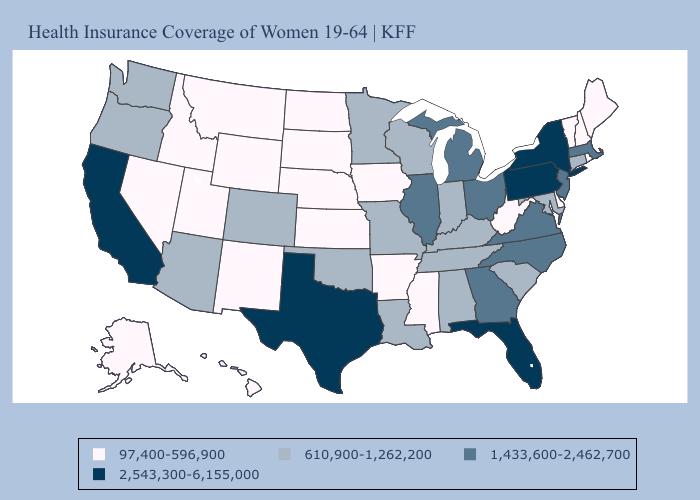What is the lowest value in the South?
Short answer required. 97,400-596,900. Does West Virginia have a higher value than Minnesota?
Be succinct. No. Name the states that have a value in the range 1,433,600-2,462,700?
Keep it brief. Georgia, Illinois, Massachusetts, Michigan, New Jersey, North Carolina, Ohio, Virginia. Does Wisconsin have the same value as South Dakota?
Answer briefly. No. What is the lowest value in states that border South Dakota?
Concise answer only. 97,400-596,900. How many symbols are there in the legend?
Be succinct. 4. Does Texas have the highest value in the USA?
Give a very brief answer. Yes. What is the value of Colorado?
Answer briefly. 610,900-1,262,200. Does Arizona have a higher value than Minnesota?
Answer briefly. No. How many symbols are there in the legend?
Answer briefly. 4. Name the states that have a value in the range 610,900-1,262,200?
Answer briefly. Alabama, Arizona, Colorado, Connecticut, Indiana, Kentucky, Louisiana, Maryland, Minnesota, Missouri, Oklahoma, Oregon, South Carolina, Tennessee, Washington, Wisconsin. Name the states that have a value in the range 2,543,300-6,155,000?
Quick response, please. California, Florida, New York, Pennsylvania, Texas. Which states have the highest value in the USA?
Concise answer only. California, Florida, New York, Pennsylvania, Texas. What is the value of Minnesota?
Quick response, please. 610,900-1,262,200. What is the value of New Mexico?
Answer briefly. 97,400-596,900. 